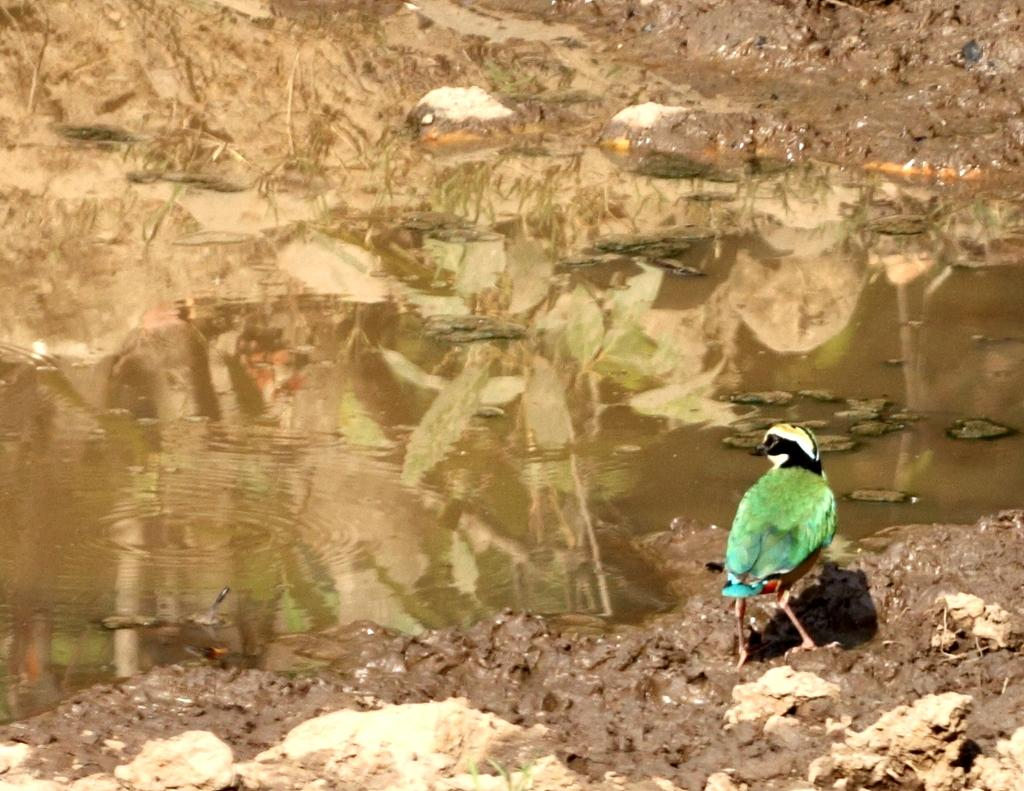What type of animal is in the image? There is a bird in the image. Where is the bird located? The bird is on the land. What colors can be seen on the bird? The bird has green, black, and white colors. What natural element is visible in the image? There is water visible in the image. What type of terrain can be seen in the background? There is mud in the background of the image. What type of brush is the bird using to paint the straw in the image? There is no brush or straw present in the image; it features a bird on the land with water and mud in the background. 